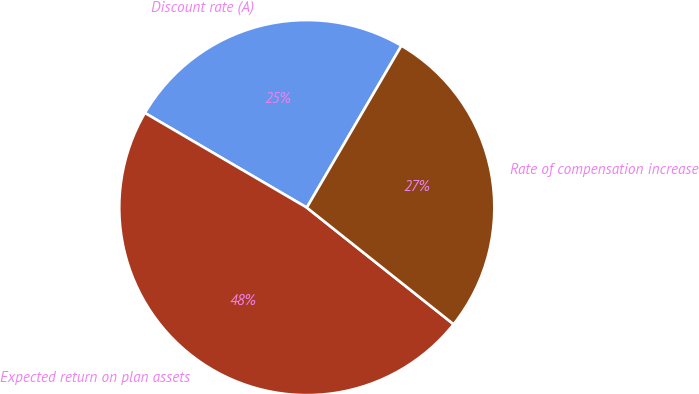<chart> <loc_0><loc_0><loc_500><loc_500><pie_chart><fcel>Discount rate (A)<fcel>Expected return on plan assets<fcel>Rate of compensation increase<nl><fcel>25.0%<fcel>47.73%<fcel>27.27%<nl></chart> 